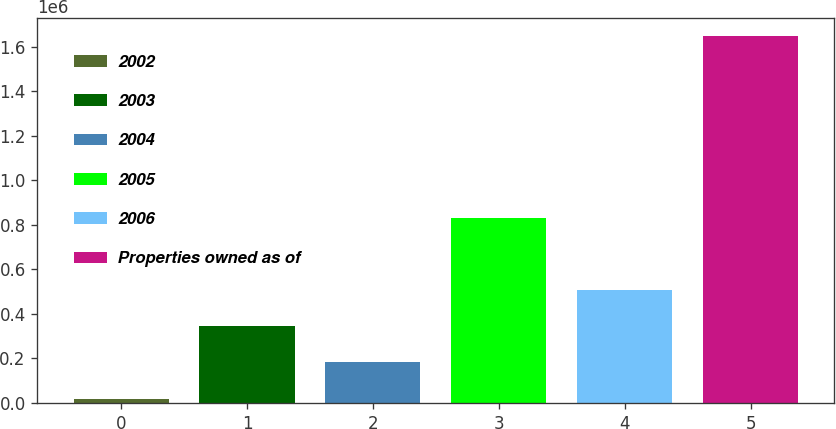Convert chart. <chart><loc_0><loc_0><loc_500><loc_500><bar_chart><fcel>2002<fcel>2003<fcel>2004<fcel>2005<fcel>2006<fcel>Properties owned as of<nl><fcel>19890<fcel>345163<fcel>182526<fcel>832252<fcel>507800<fcel>1.64626e+06<nl></chart> 